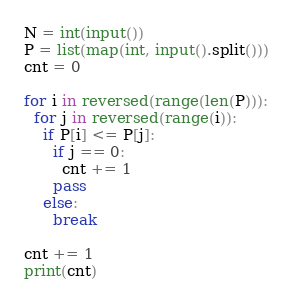<code> <loc_0><loc_0><loc_500><loc_500><_Python_>N = int(input())
P = list(map(int, input().split()))
cnt = 0

for i in reversed(range(len(P))):
  for j in reversed(range(i)):
    if P[i] <= P[j]:
      if j == 0:
        cnt += 1
      pass
    else:
      break

cnt += 1
print(cnt)
</code> 